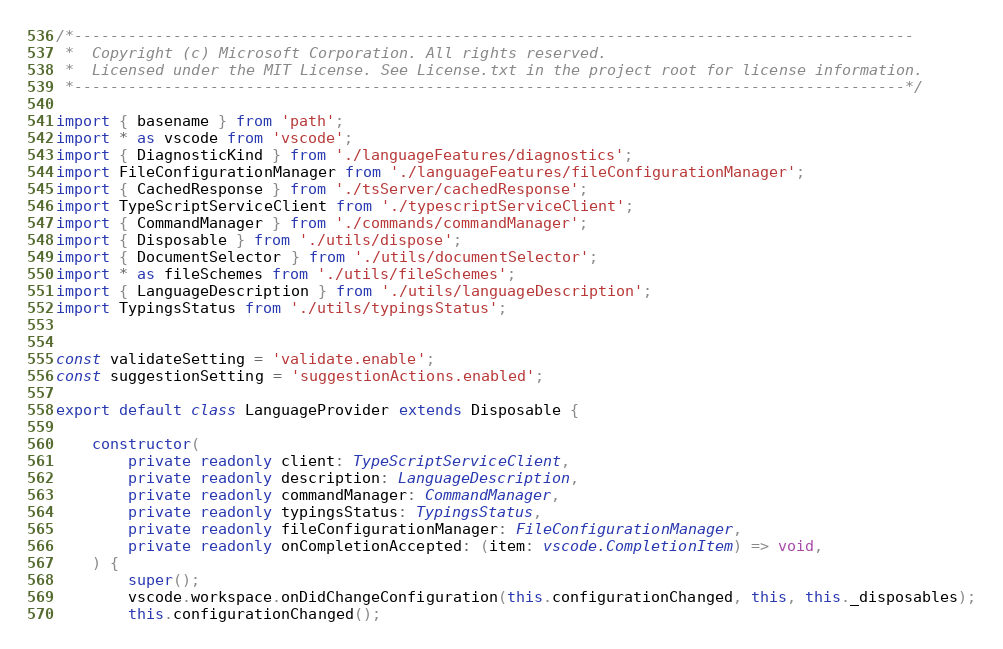<code> <loc_0><loc_0><loc_500><loc_500><_TypeScript_>/*---------------------------------------------------------------------------------------------
 *  Copyright (c) Microsoft Corporation. All rights reserved.
 *  Licensed under the MIT License. See License.txt in the project root for license information.
 *--------------------------------------------------------------------------------------------*/

import { basename } from 'path';
import * as vscode from 'vscode';
import { DiagnosticKind } from './languageFeatures/diagnostics';
import FileConfigurationManager from './languageFeatures/fileConfigurationManager';
import { CachedResponse } from './tsServer/cachedResponse';
import TypeScriptServiceClient from './typescriptServiceClient';
import { CommandManager } from './commands/commandManager';
import { Disposable } from './utils/dispose';
import { DocumentSelector } from './utils/documentSelector';
import * as fileSchemes from './utils/fileSchemes';
import { LanguageDescription } from './utils/languageDescription';
import TypingsStatus from './utils/typingsStatus';


const validateSetting = 'validate.enable';
const suggestionSetting = 'suggestionActions.enabled';

export default class LanguageProvider extends Disposable {

	constructor(
		private readonly client: TypeScriptServiceClient,
		private readonly description: LanguageDescription,
		private readonly commandManager: CommandManager,
		private readonly typingsStatus: TypingsStatus,
		private readonly fileConfigurationManager: FileConfigurationManager,
		private readonly onCompletionAccepted: (item: vscode.CompletionItem) => void,
	) {
		super();
		vscode.workspace.onDidChangeConfiguration(this.configurationChanged, this, this._disposables);
		this.configurationChanged();
</code> 